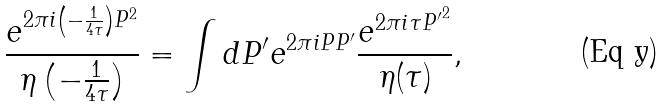Convert formula to latex. <formula><loc_0><loc_0><loc_500><loc_500>\frac { e ^ { 2 \pi i \left ( - \frac { 1 } { 4 \tau } \right ) P ^ { 2 } } } { \eta \left ( - \frac { 1 } { 4 \tau } \right ) } = \int d P ^ { \prime } e ^ { 2 \pi i P P ^ { \prime } } \frac { e ^ { 2 \pi i \tau { P ^ { \prime } } ^ { 2 } } } { \eta ( \tau ) } ,</formula> 